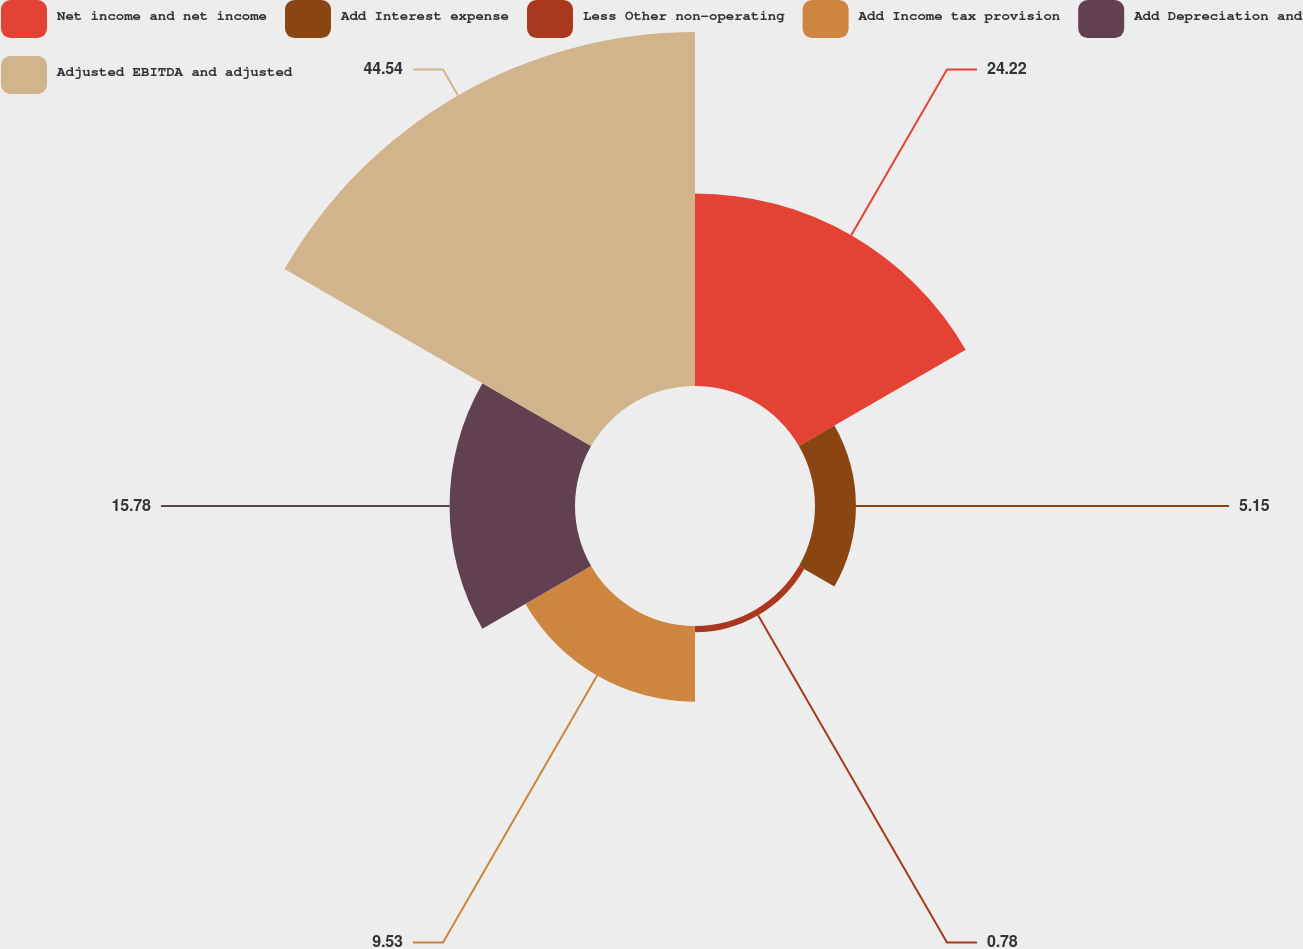Convert chart to OTSL. <chart><loc_0><loc_0><loc_500><loc_500><pie_chart><fcel>Net income and net income<fcel>Add Interest expense<fcel>Less Other non-operating<fcel>Add Income tax provision<fcel>Add Depreciation and<fcel>Adjusted EBITDA and adjusted<nl><fcel>24.22%<fcel>5.15%<fcel>0.78%<fcel>9.53%<fcel>15.78%<fcel>44.53%<nl></chart> 